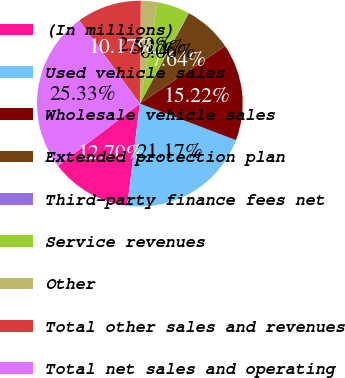Convert chart. <chart><loc_0><loc_0><loc_500><loc_500><pie_chart><fcel>(In millions)<fcel>Used vehicle sales<fcel>Wholesale vehicle sales<fcel>Extended protection plan<fcel>Third-party finance fees net<fcel>Service revenues<fcel>Other<fcel>Total other sales and revenues<fcel>Total net sales and operating<nl><fcel>12.7%<fcel>21.17%<fcel>15.22%<fcel>7.64%<fcel>0.06%<fcel>5.12%<fcel>2.59%<fcel>10.17%<fcel>25.33%<nl></chart> 